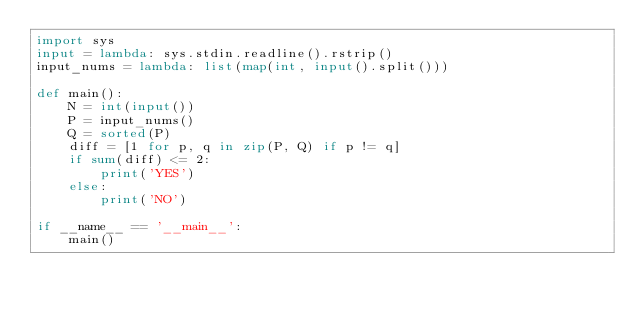<code> <loc_0><loc_0><loc_500><loc_500><_Python_>import sys
input = lambda: sys.stdin.readline().rstrip()
input_nums = lambda: list(map(int, input().split()))

def main():
    N = int(input())
    P = input_nums()
    Q = sorted(P)
    diff = [1 for p, q in zip(P, Q) if p != q]
    if sum(diff) <= 2:
        print('YES')
    else:
        print('NO')

if __name__ == '__main__':
    main()
</code> 